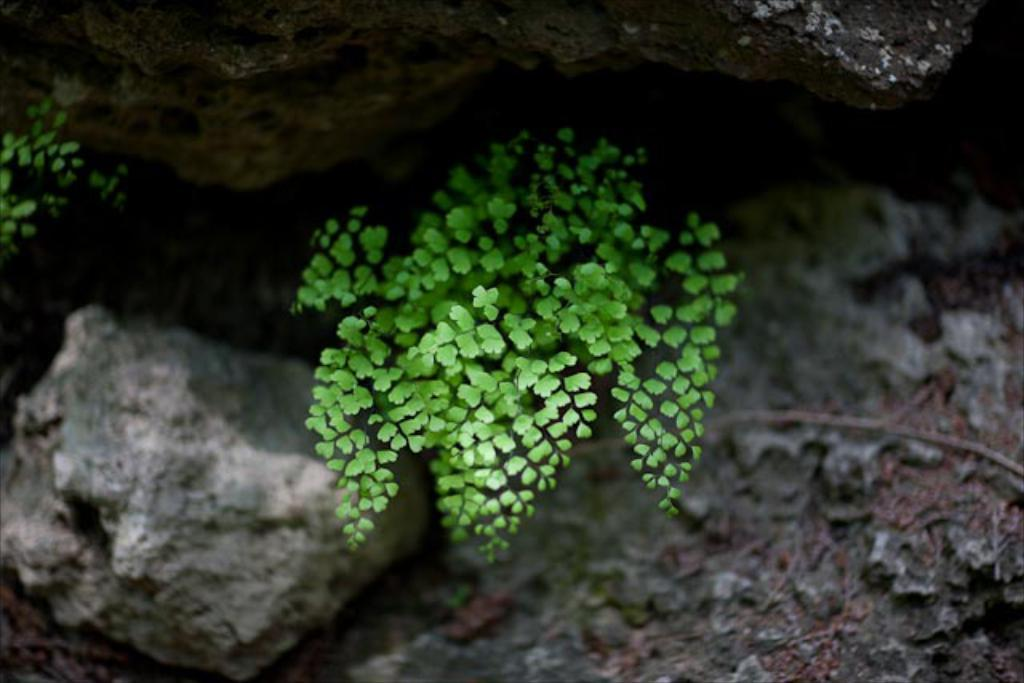What type of living organisms can be seen in the image? Plants can be seen in the image. What type of natural elements are visible in the background of the image? Rocks are visible in the background of the image. What type of winter clothing is the airplane wearing in the image? There is no airplane present in the image, and therefore no winter clothing can be observed. 